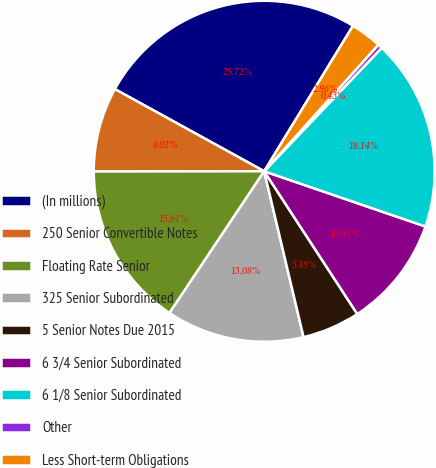<chart> <loc_0><loc_0><loc_500><loc_500><pie_chart><fcel>(In millions)<fcel>250 Senior Convertible Notes<fcel>Floating Rate Senior<fcel>325 Senior Subordinated<fcel>5 Senior Notes Due 2015<fcel>6 3/4 Senior Subordinated<fcel>6 1/8 Senior Subordinated<fcel>Other<fcel>Less Short-term Obligations<nl><fcel>25.72%<fcel>8.02%<fcel>15.61%<fcel>13.08%<fcel>5.49%<fcel>10.55%<fcel>18.14%<fcel>0.43%<fcel>2.96%<nl></chart> 